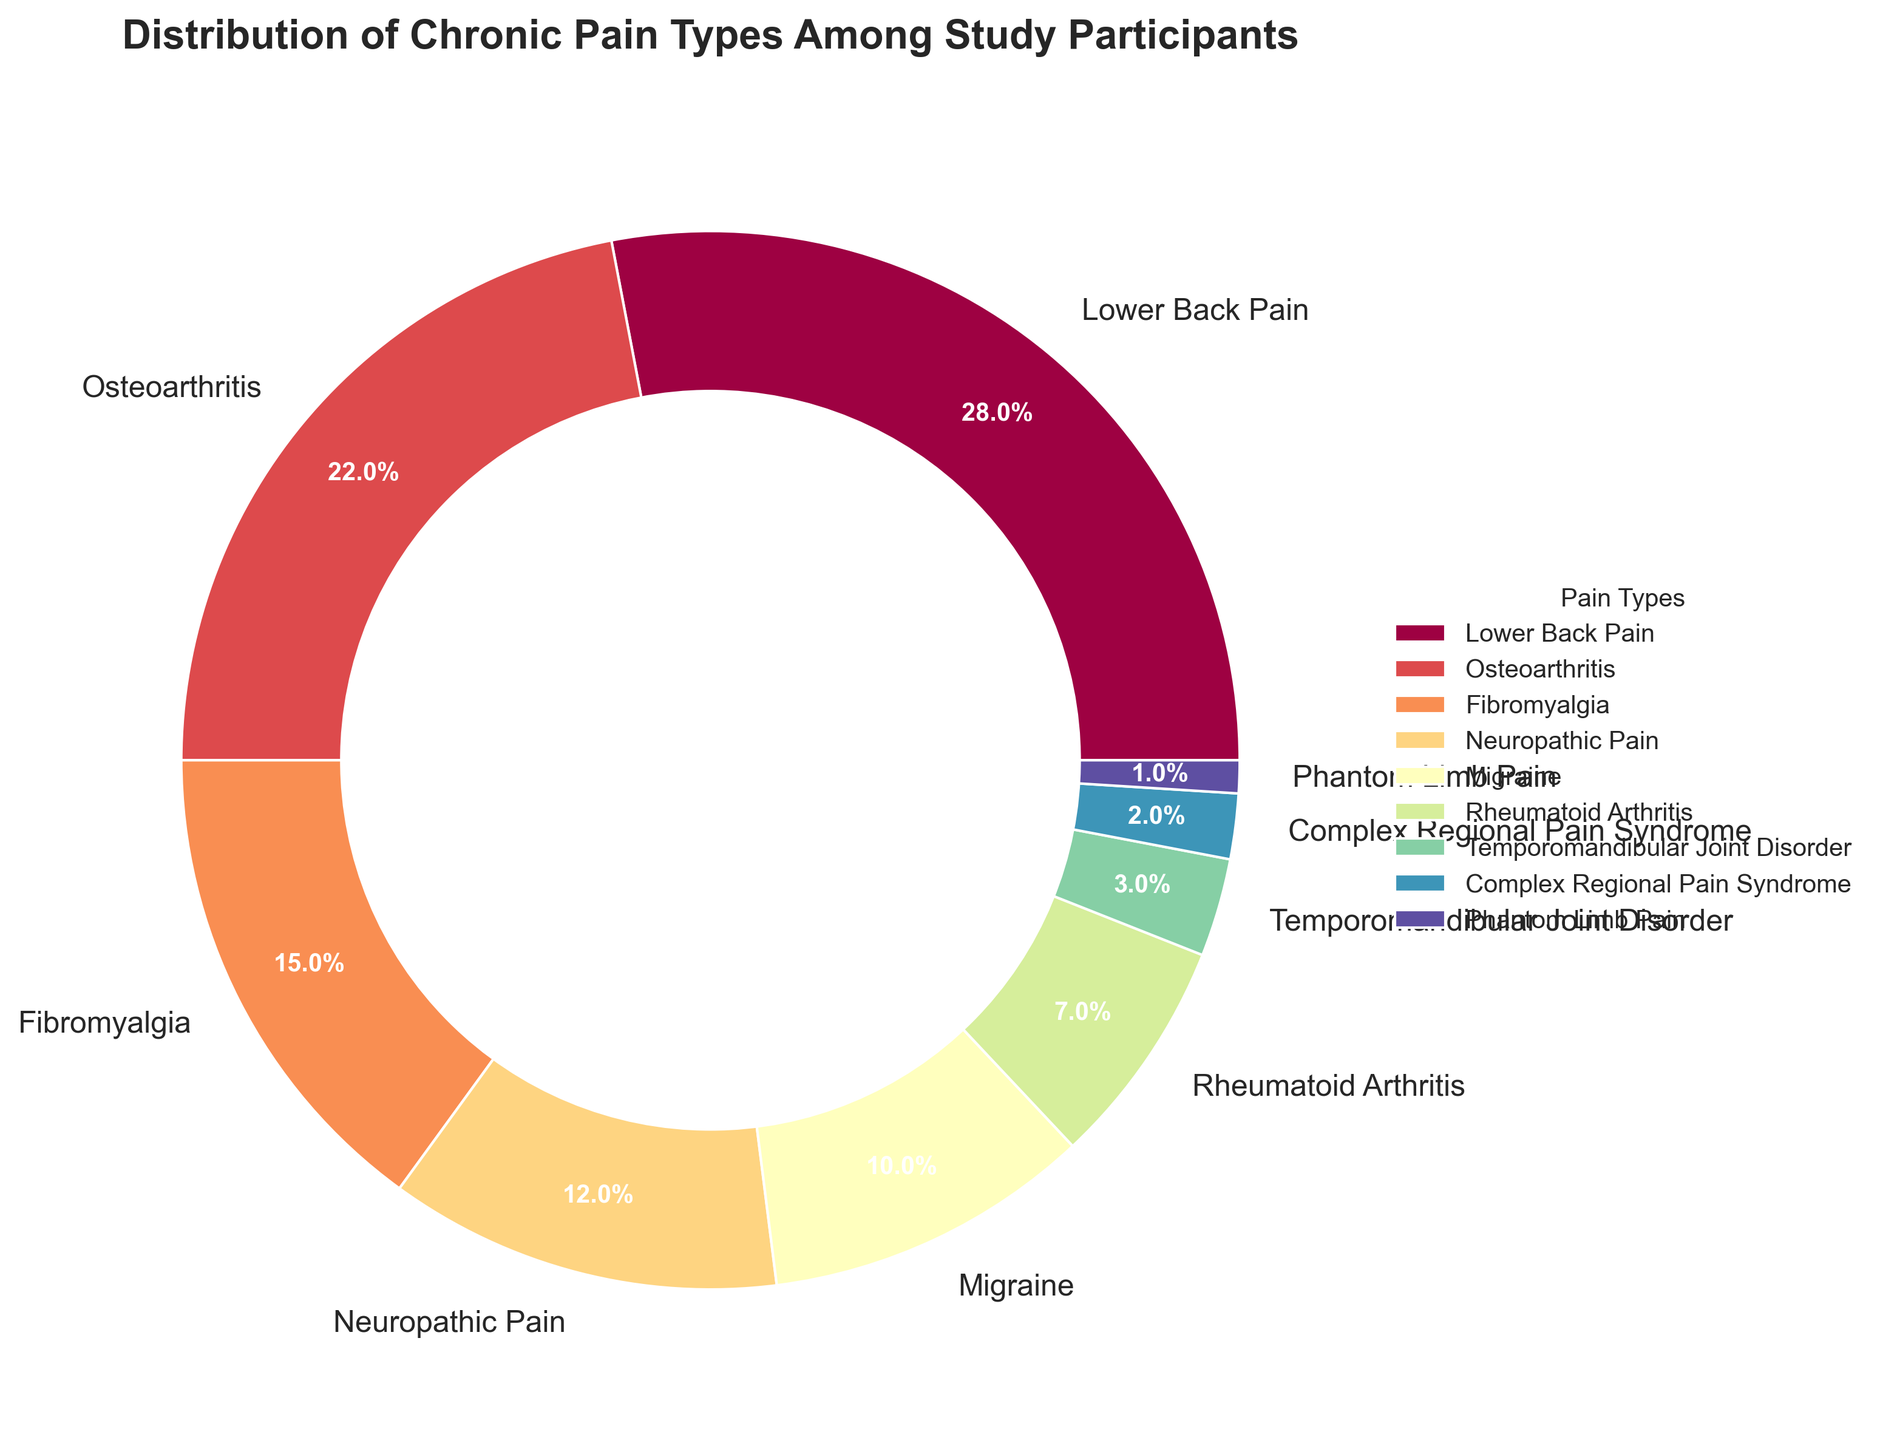What is the most common type of chronic pain among the study participants? Look at the pie chart and find the segment with the largest percentage. The largest segment represents Lower Back Pain with 28%.
Answer: Lower Back Pain Which type of chronic pain affects a higher percentage of participants: Migraine or Rheumatoid Arthritis? Compare the pie chart segment labels for Migraine and Rheumatoid Arthritis. Migraine has 10% while Rheumatoid Arthritis has 7%.
Answer: Migraine What is the combined percentage of study participants suffering from both Neuropathic Pain and Fibromyalgia? Add the percentages for Neuropathic Pain and Fibromyalgia from the pie chart. Neuropathic Pain is 12% and Fibromyalgia is 15%, so 12% + 15% = 27%.
Answer: 27% How many types of chronic pain account for less than 5% of the participants each? Look at the pie chart and count the number of segments with less than 5%. There are three such types: Temporomandibular Joint Disorder (3%), Complex Regional Pain Syndrome (2%), and Phantom Limb Pain (1%).
Answer: 3 Is Osteoarthritis more prevalent than Neuropathic Pain? Compare the percentages for Osteoarthritis and Neuropathic Pain from the pie chart. Osteoarthritis is 22% and Neuropathic Pain is 12%.
Answer: Yes What is the percentage difference between the most and least common types of chronic pain? The most common type is Lower Back Pain (28%) and the least common is Phantom Limb Pain (1%). Subtract the least common from the most common: 28% - 1% = 27%.
Answer: 27% Which chronic pain type has the smallest percentage in the study participants? Look at the pie chart and find the segment with the smallest percentage which is Phantom Limb Pain at 1%.
Answer: Phantom Limb Pain What visually distinguishes the segment representing Lower Back Pain from others in the pie chart? Look at visual attributes such as size. The segment representing Lower Back Pain is visibly the largest compared to other segments in the pie chart.
Answer: It is the largest segment Which chronic pain types are represented by segments that are visually close in size? Look at similarly sized segments in the pie chart. Osteoarthritis (22%) and Fibromyalgia (15%) are relatively close in size.
Answer: Osteoarthritis and Fibromyalgia If we combine the percentages of Migraine, Rheumatoid Arthritis, and Temporomandibular Joint Disorder, what is the total? Add the percentages for Migraine, Rheumatoid Arthritis, and Temporomandibular Joint Disorder: 10% + 7% + 3% = 20%.
Answer: 20% 